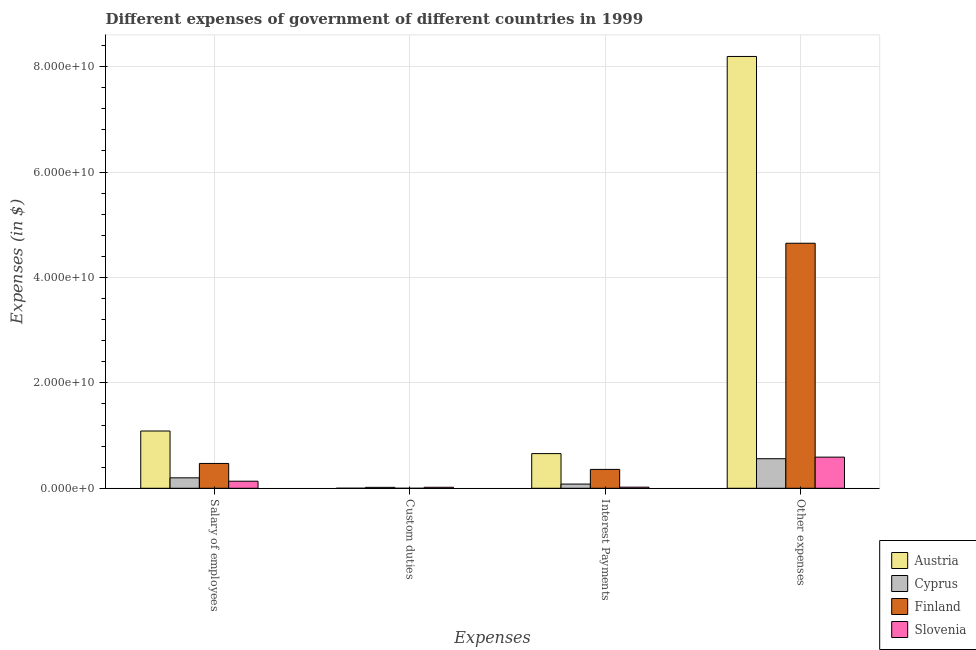How many different coloured bars are there?
Offer a very short reply. 4. How many groups of bars are there?
Ensure brevity in your answer.  4. What is the label of the 2nd group of bars from the left?
Make the answer very short. Custom duties. What is the amount spent on custom duties in Slovenia?
Your answer should be compact. 1.91e+08. Across all countries, what is the maximum amount spent on interest payments?
Make the answer very short. 6.58e+09. Across all countries, what is the minimum amount spent on other expenses?
Provide a succinct answer. 5.61e+09. In which country was the amount spent on interest payments maximum?
Your answer should be very brief. Austria. What is the total amount spent on other expenses in the graph?
Give a very brief answer. 1.40e+11. What is the difference between the amount spent on custom duties in Slovenia and that in Austria?
Offer a terse response. 1.84e+08. What is the difference between the amount spent on custom duties in Austria and the amount spent on other expenses in Slovenia?
Your response must be concise. -5.90e+09. What is the average amount spent on interest payments per country?
Your response must be concise. 2.79e+09. What is the difference between the amount spent on salary of employees and amount spent on interest payments in Cyprus?
Provide a succinct answer. 1.18e+09. What is the ratio of the amount spent on other expenses in Cyprus to that in Slovenia?
Your response must be concise. 0.95. Is the difference between the amount spent on custom duties in Austria and Slovenia greater than the difference between the amount spent on salary of employees in Austria and Slovenia?
Ensure brevity in your answer.  No. What is the difference between the highest and the second highest amount spent on salary of employees?
Offer a very short reply. 6.15e+09. What is the difference between the highest and the lowest amount spent on salary of employees?
Make the answer very short. 9.53e+09. Is it the case that in every country, the sum of the amount spent on salary of employees and amount spent on custom duties is greater than the amount spent on interest payments?
Give a very brief answer. Yes. Does the graph contain any zero values?
Give a very brief answer. Yes. How many legend labels are there?
Offer a very short reply. 4. How are the legend labels stacked?
Your answer should be very brief. Vertical. What is the title of the graph?
Provide a short and direct response. Different expenses of government of different countries in 1999. Does "Latvia" appear as one of the legend labels in the graph?
Your response must be concise. No. What is the label or title of the X-axis?
Offer a very short reply. Expenses. What is the label or title of the Y-axis?
Offer a terse response. Expenses (in $). What is the Expenses (in $) in Austria in Salary of employees?
Provide a short and direct response. 1.09e+1. What is the Expenses (in $) of Cyprus in Salary of employees?
Provide a succinct answer. 1.98e+09. What is the Expenses (in $) of Finland in Salary of employees?
Offer a terse response. 4.71e+09. What is the Expenses (in $) of Slovenia in Salary of employees?
Offer a terse response. 1.34e+09. What is the Expenses (in $) in Austria in Custom duties?
Make the answer very short. 6.85e+06. What is the Expenses (in $) in Cyprus in Custom duties?
Your response must be concise. 1.75e+08. What is the Expenses (in $) in Finland in Custom duties?
Offer a very short reply. 0. What is the Expenses (in $) in Slovenia in Custom duties?
Your response must be concise. 1.91e+08. What is the Expenses (in $) of Austria in Interest Payments?
Offer a very short reply. 6.58e+09. What is the Expenses (in $) in Cyprus in Interest Payments?
Make the answer very short. 7.99e+08. What is the Expenses (in $) of Finland in Interest Payments?
Make the answer very short. 3.58e+09. What is the Expenses (in $) of Slovenia in Interest Payments?
Provide a short and direct response. 2.11e+08. What is the Expenses (in $) in Austria in Other expenses?
Offer a terse response. 8.19e+1. What is the Expenses (in $) in Cyprus in Other expenses?
Provide a short and direct response. 5.61e+09. What is the Expenses (in $) of Finland in Other expenses?
Your answer should be compact. 4.65e+1. What is the Expenses (in $) of Slovenia in Other expenses?
Provide a succinct answer. 5.91e+09. Across all Expenses, what is the maximum Expenses (in $) in Austria?
Your answer should be compact. 8.19e+1. Across all Expenses, what is the maximum Expenses (in $) of Cyprus?
Make the answer very short. 5.61e+09. Across all Expenses, what is the maximum Expenses (in $) of Finland?
Your answer should be compact. 4.65e+1. Across all Expenses, what is the maximum Expenses (in $) in Slovenia?
Your response must be concise. 5.91e+09. Across all Expenses, what is the minimum Expenses (in $) in Austria?
Provide a short and direct response. 6.85e+06. Across all Expenses, what is the minimum Expenses (in $) of Cyprus?
Your answer should be compact. 1.75e+08. Across all Expenses, what is the minimum Expenses (in $) in Slovenia?
Give a very brief answer. 1.91e+08. What is the total Expenses (in $) of Austria in the graph?
Your answer should be very brief. 9.94e+1. What is the total Expenses (in $) of Cyprus in the graph?
Keep it short and to the point. 8.56e+09. What is the total Expenses (in $) of Finland in the graph?
Your answer should be compact. 5.48e+1. What is the total Expenses (in $) of Slovenia in the graph?
Your answer should be very brief. 7.65e+09. What is the difference between the Expenses (in $) in Austria in Salary of employees and that in Custom duties?
Provide a succinct answer. 1.09e+1. What is the difference between the Expenses (in $) of Cyprus in Salary of employees and that in Custom duties?
Offer a very short reply. 1.81e+09. What is the difference between the Expenses (in $) in Slovenia in Salary of employees and that in Custom duties?
Offer a very short reply. 1.15e+09. What is the difference between the Expenses (in $) of Austria in Salary of employees and that in Interest Payments?
Provide a short and direct response. 4.29e+09. What is the difference between the Expenses (in $) in Cyprus in Salary of employees and that in Interest Payments?
Keep it short and to the point. 1.18e+09. What is the difference between the Expenses (in $) of Finland in Salary of employees and that in Interest Payments?
Your answer should be very brief. 1.13e+09. What is the difference between the Expenses (in $) of Slovenia in Salary of employees and that in Interest Payments?
Make the answer very short. 1.13e+09. What is the difference between the Expenses (in $) of Austria in Salary of employees and that in Other expenses?
Your answer should be very brief. -7.11e+1. What is the difference between the Expenses (in $) of Cyprus in Salary of employees and that in Other expenses?
Offer a terse response. -3.63e+09. What is the difference between the Expenses (in $) in Finland in Salary of employees and that in Other expenses?
Provide a succinct answer. -4.18e+1. What is the difference between the Expenses (in $) in Slovenia in Salary of employees and that in Other expenses?
Your response must be concise. -4.57e+09. What is the difference between the Expenses (in $) in Austria in Custom duties and that in Interest Payments?
Ensure brevity in your answer.  -6.57e+09. What is the difference between the Expenses (in $) of Cyprus in Custom duties and that in Interest Payments?
Ensure brevity in your answer.  -6.23e+08. What is the difference between the Expenses (in $) of Slovenia in Custom duties and that in Interest Payments?
Offer a very short reply. -2.00e+07. What is the difference between the Expenses (in $) in Austria in Custom duties and that in Other expenses?
Offer a terse response. -8.19e+1. What is the difference between the Expenses (in $) in Cyprus in Custom duties and that in Other expenses?
Ensure brevity in your answer.  -5.43e+09. What is the difference between the Expenses (in $) in Slovenia in Custom duties and that in Other expenses?
Offer a terse response. -5.72e+09. What is the difference between the Expenses (in $) in Austria in Interest Payments and that in Other expenses?
Keep it short and to the point. -7.54e+1. What is the difference between the Expenses (in $) in Cyprus in Interest Payments and that in Other expenses?
Your answer should be compact. -4.81e+09. What is the difference between the Expenses (in $) in Finland in Interest Payments and that in Other expenses?
Offer a terse response. -4.29e+1. What is the difference between the Expenses (in $) of Slovenia in Interest Payments and that in Other expenses?
Keep it short and to the point. -5.70e+09. What is the difference between the Expenses (in $) in Austria in Salary of employees and the Expenses (in $) in Cyprus in Custom duties?
Your answer should be very brief. 1.07e+1. What is the difference between the Expenses (in $) of Austria in Salary of employees and the Expenses (in $) of Slovenia in Custom duties?
Your response must be concise. 1.07e+1. What is the difference between the Expenses (in $) in Cyprus in Salary of employees and the Expenses (in $) in Slovenia in Custom duties?
Make the answer very short. 1.79e+09. What is the difference between the Expenses (in $) in Finland in Salary of employees and the Expenses (in $) in Slovenia in Custom duties?
Your answer should be compact. 4.52e+09. What is the difference between the Expenses (in $) in Austria in Salary of employees and the Expenses (in $) in Cyprus in Interest Payments?
Keep it short and to the point. 1.01e+1. What is the difference between the Expenses (in $) of Austria in Salary of employees and the Expenses (in $) of Finland in Interest Payments?
Your answer should be very brief. 7.28e+09. What is the difference between the Expenses (in $) of Austria in Salary of employees and the Expenses (in $) of Slovenia in Interest Payments?
Offer a very short reply. 1.07e+1. What is the difference between the Expenses (in $) in Cyprus in Salary of employees and the Expenses (in $) in Finland in Interest Payments?
Offer a terse response. -1.60e+09. What is the difference between the Expenses (in $) of Cyprus in Salary of employees and the Expenses (in $) of Slovenia in Interest Payments?
Offer a very short reply. 1.77e+09. What is the difference between the Expenses (in $) in Finland in Salary of employees and the Expenses (in $) in Slovenia in Interest Payments?
Make the answer very short. 4.50e+09. What is the difference between the Expenses (in $) in Austria in Salary of employees and the Expenses (in $) in Cyprus in Other expenses?
Provide a short and direct response. 5.26e+09. What is the difference between the Expenses (in $) in Austria in Salary of employees and the Expenses (in $) in Finland in Other expenses?
Make the answer very short. -3.56e+1. What is the difference between the Expenses (in $) of Austria in Salary of employees and the Expenses (in $) of Slovenia in Other expenses?
Your response must be concise. 4.96e+09. What is the difference between the Expenses (in $) of Cyprus in Salary of employees and the Expenses (in $) of Finland in Other expenses?
Offer a very short reply. -4.45e+1. What is the difference between the Expenses (in $) in Cyprus in Salary of employees and the Expenses (in $) in Slovenia in Other expenses?
Make the answer very short. -3.93e+09. What is the difference between the Expenses (in $) in Finland in Salary of employees and the Expenses (in $) in Slovenia in Other expenses?
Keep it short and to the point. -1.20e+09. What is the difference between the Expenses (in $) of Austria in Custom duties and the Expenses (in $) of Cyprus in Interest Payments?
Make the answer very short. -7.92e+08. What is the difference between the Expenses (in $) in Austria in Custom duties and the Expenses (in $) in Finland in Interest Payments?
Offer a very short reply. -3.58e+09. What is the difference between the Expenses (in $) in Austria in Custom duties and the Expenses (in $) in Slovenia in Interest Payments?
Your answer should be very brief. -2.04e+08. What is the difference between the Expenses (in $) of Cyprus in Custom duties and the Expenses (in $) of Finland in Interest Payments?
Your answer should be compact. -3.41e+09. What is the difference between the Expenses (in $) in Cyprus in Custom duties and the Expenses (in $) in Slovenia in Interest Payments?
Keep it short and to the point. -3.53e+07. What is the difference between the Expenses (in $) in Austria in Custom duties and the Expenses (in $) in Cyprus in Other expenses?
Keep it short and to the point. -5.60e+09. What is the difference between the Expenses (in $) of Austria in Custom duties and the Expenses (in $) of Finland in Other expenses?
Give a very brief answer. -4.65e+1. What is the difference between the Expenses (in $) of Austria in Custom duties and the Expenses (in $) of Slovenia in Other expenses?
Provide a succinct answer. -5.90e+09. What is the difference between the Expenses (in $) of Cyprus in Custom duties and the Expenses (in $) of Finland in Other expenses?
Provide a succinct answer. -4.63e+1. What is the difference between the Expenses (in $) of Cyprus in Custom duties and the Expenses (in $) of Slovenia in Other expenses?
Give a very brief answer. -5.73e+09. What is the difference between the Expenses (in $) of Austria in Interest Payments and the Expenses (in $) of Cyprus in Other expenses?
Your response must be concise. 9.74e+08. What is the difference between the Expenses (in $) of Austria in Interest Payments and the Expenses (in $) of Finland in Other expenses?
Keep it short and to the point. -3.99e+1. What is the difference between the Expenses (in $) of Austria in Interest Payments and the Expenses (in $) of Slovenia in Other expenses?
Offer a terse response. 6.72e+08. What is the difference between the Expenses (in $) of Cyprus in Interest Payments and the Expenses (in $) of Finland in Other expenses?
Ensure brevity in your answer.  -4.57e+1. What is the difference between the Expenses (in $) of Cyprus in Interest Payments and the Expenses (in $) of Slovenia in Other expenses?
Ensure brevity in your answer.  -5.11e+09. What is the difference between the Expenses (in $) in Finland in Interest Payments and the Expenses (in $) in Slovenia in Other expenses?
Your answer should be compact. -2.33e+09. What is the average Expenses (in $) of Austria per Expenses?
Your answer should be very brief. 2.48e+1. What is the average Expenses (in $) in Cyprus per Expenses?
Give a very brief answer. 2.14e+09. What is the average Expenses (in $) in Finland per Expenses?
Provide a short and direct response. 1.37e+1. What is the average Expenses (in $) of Slovenia per Expenses?
Offer a very short reply. 1.91e+09. What is the difference between the Expenses (in $) in Austria and Expenses (in $) in Cyprus in Salary of employees?
Make the answer very short. 8.89e+09. What is the difference between the Expenses (in $) in Austria and Expenses (in $) in Finland in Salary of employees?
Make the answer very short. 6.15e+09. What is the difference between the Expenses (in $) of Austria and Expenses (in $) of Slovenia in Salary of employees?
Your answer should be compact. 9.53e+09. What is the difference between the Expenses (in $) in Cyprus and Expenses (in $) in Finland in Salary of employees?
Provide a succinct answer. -2.73e+09. What is the difference between the Expenses (in $) of Cyprus and Expenses (in $) of Slovenia in Salary of employees?
Provide a short and direct response. 6.40e+08. What is the difference between the Expenses (in $) of Finland and Expenses (in $) of Slovenia in Salary of employees?
Keep it short and to the point. 3.37e+09. What is the difference between the Expenses (in $) of Austria and Expenses (in $) of Cyprus in Custom duties?
Provide a succinct answer. -1.69e+08. What is the difference between the Expenses (in $) of Austria and Expenses (in $) of Slovenia in Custom duties?
Provide a succinct answer. -1.84e+08. What is the difference between the Expenses (in $) of Cyprus and Expenses (in $) of Slovenia in Custom duties?
Your answer should be very brief. -1.52e+07. What is the difference between the Expenses (in $) of Austria and Expenses (in $) of Cyprus in Interest Payments?
Make the answer very short. 5.78e+09. What is the difference between the Expenses (in $) of Austria and Expenses (in $) of Finland in Interest Payments?
Offer a very short reply. 3.00e+09. What is the difference between the Expenses (in $) of Austria and Expenses (in $) of Slovenia in Interest Payments?
Offer a terse response. 6.37e+09. What is the difference between the Expenses (in $) of Cyprus and Expenses (in $) of Finland in Interest Payments?
Ensure brevity in your answer.  -2.79e+09. What is the difference between the Expenses (in $) in Cyprus and Expenses (in $) in Slovenia in Interest Payments?
Make the answer very short. 5.88e+08. What is the difference between the Expenses (in $) in Finland and Expenses (in $) in Slovenia in Interest Payments?
Your answer should be very brief. 3.37e+09. What is the difference between the Expenses (in $) in Austria and Expenses (in $) in Cyprus in Other expenses?
Make the answer very short. 7.63e+1. What is the difference between the Expenses (in $) in Austria and Expenses (in $) in Finland in Other expenses?
Your response must be concise. 3.54e+1. What is the difference between the Expenses (in $) of Austria and Expenses (in $) of Slovenia in Other expenses?
Your answer should be very brief. 7.60e+1. What is the difference between the Expenses (in $) in Cyprus and Expenses (in $) in Finland in Other expenses?
Keep it short and to the point. -4.09e+1. What is the difference between the Expenses (in $) of Cyprus and Expenses (in $) of Slovenia in Other expenses?
Offer a very short reply. -3.02e+08. What is the difference between the Expenses (in $) of Finland and Expenses (in $) of Slovenia in Other expenses?
Your answer should be compact. 4.06e+1. What is the ratio of the Expenses (in $) of Austria in Salary of employees to that in Custom duties?
Provide a succinct answer. 1586.61. What is the ratio of the Expenses (in $) of Cyprus in Salary of employees to that in Custom duties?
Give a very brief answer. 11.29. What is the ratio of the Expenses (in $) in Slovenia in Salary of employees to that in Custom duties?
Your answer should be very brief. 7.03. What is the ratio of the Expenses (in $) of Austria in Salary of employees to that in Interest Payments?
Offer a terse response. 1.65. What is the ratio of the Expenses (in $) in Cyprus in Salary of employees to that in Interest Payments?
Provide a short and direct response. 2.48. What is the ratio of the Expenses (in $) in Finland in Salary of employees to that in Interest Payments?
Offer a very short reply. 1.32. What is the ratio of the Expenses (in $) in Slovenia in Salary of employees to that in Interest Payments?
Your answer should be very brief. 6.36. What is the ratio of the Expenses (in $) of Austria in Salary of employees to that in Other expenses?
Your answer should be compact. 0.13. What is the ratio of the Expenses (in $) of Cyprus in Salary of employees to that in Other expenses?
Offer a terse response. 0.35. What is the ratio of the Expenses (in $) of Finland in Salary of employees to that in Other expenses?
Your answer should be compact. 0.1. What is the ratio of the Expenses (in $) in Slovenia in Salary of employees to that in Other expenses?
Your response must be concise. 0.23. What is the ratio of the Expenses (in $) of Cyprus in Custom duties to that in Interest Payments?
Make the answer very short. 0.22. What is the ratio of the Expenses (in $) in Slovenia in Custom duties to that in Interest Payments?
Give a very brief answer. 0.91. What is the ratio of the Expenses (in $) of Cyprus in Custom duties to that in Other expenses?
Your answer should be very brief. 0.03. What is the ratio of the Expenses (in $) in Slovenia in Custom duties to that in Other expenses?
Ensure brevity in your answer.  0.03. What is the ratio of the Expenses (in $) in Austria in Interest Payments to that in Other expenses?
Provide a succinct answer. 0.08. What is the ratio of the Expenses (in $) of Cyprus in Interest Payments to that in Other expenses?
Keep it short and to the point. 0.14. What is the ratio of the Expenses (in $) in Finland in Interest Payments to that in Other expenses?
Provide a short and direct response. 0.08. What is the ratio of the Expenses (in $) of Slovenia in Interest Payments to that in Other expenses?
Your answer should be compact. 0.04. What is the difference between the highest and the second highest Expenses (in $) of Austria?
Your answer should be very brief. 7.11e+1. What is the difference between the highest and the second highest Expenses (in $) in Cyprus?
Your answer should be compact. 3.63e+09. What is the difference between the highest and the second highest Expenses (in $) of Finland?
Provide a short and direct response. 4.18e+1. What is the difference between the highest and the second highest Expenses (in $) in Slovenia?
Give a very brief answer. 4.57e+09. What is the difference between the highest and the lowest Expenses (in $) in Austria?
Provide a succinct answer. 8.19e+1. What is the difference between the highest and the lowest Expenses (in $) of Cyprus?
Offer a very short reply. 5.43e+09. What is the difference between the highest and the lowest Expenses (in $) in Finland?
Your response must be concise. 4.65e+1. What is the difference between the highest and the lowest Expenses (in $) of Slovenia?
Give a very brief answer. 5.72e+09. 